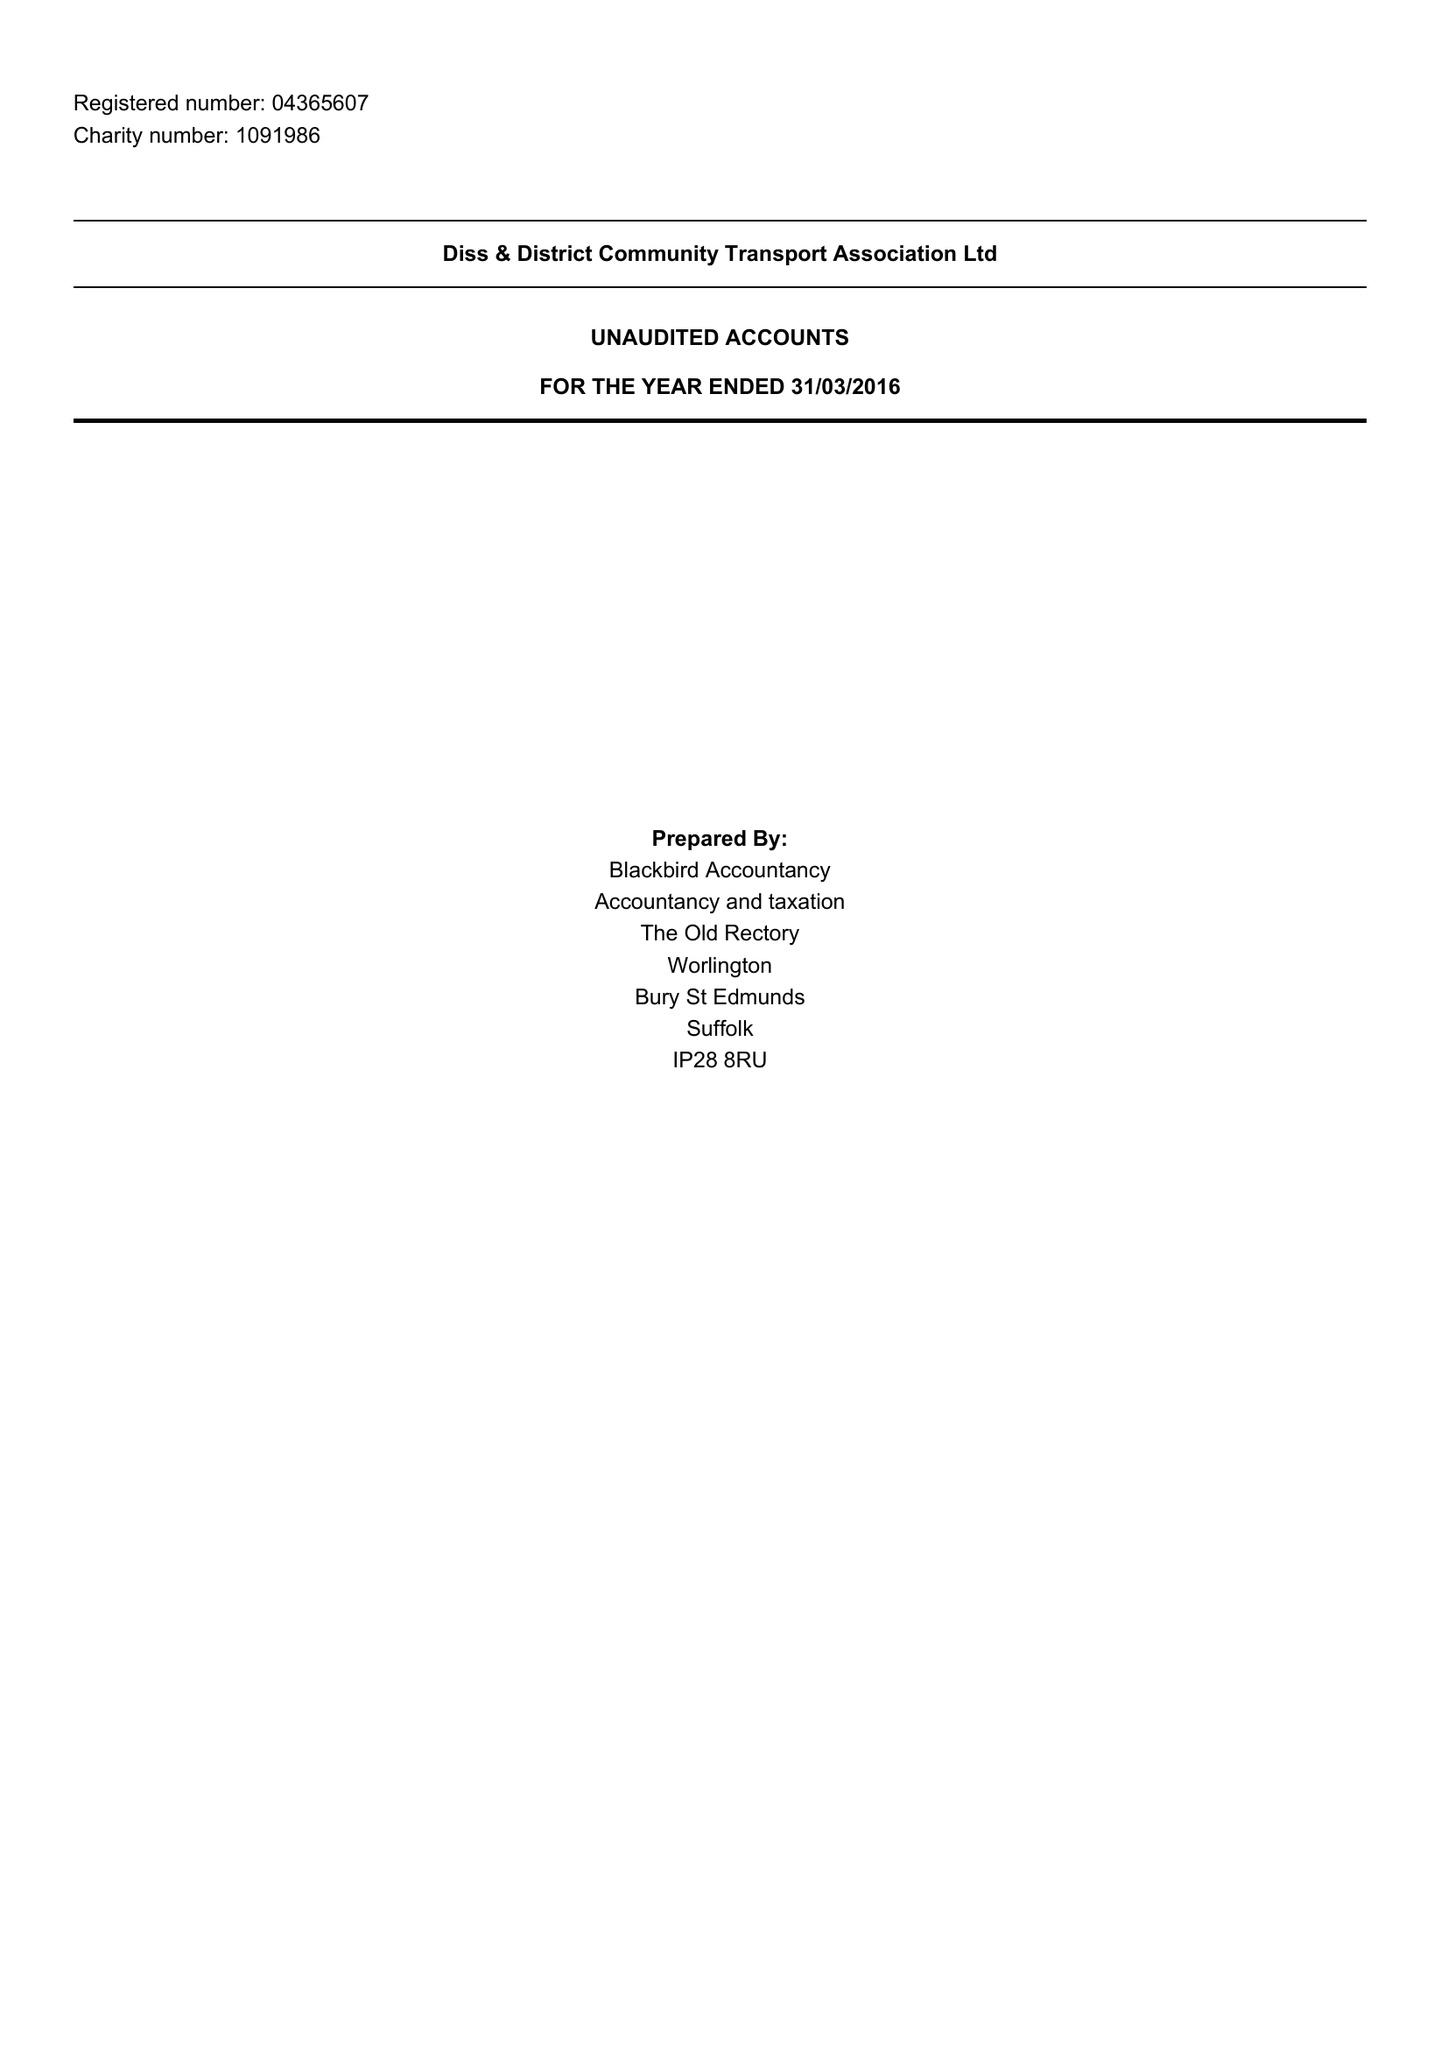What is the value for the report_date?
Answer the question using a single word or phrase. 2016-03-31 